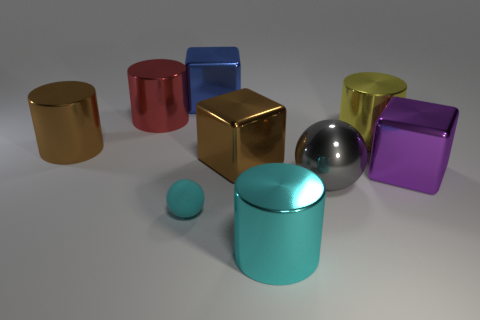Subtract 1 cylinders. How many cylinders are left? 3 Add 1 big cyan objects. How many objects exist? 10 Subtract all cubes. How many objects are left? 6 Add 4 large brown shiny things. How many large brown shiny things exist? 6 Subtract 1 blue cubes. How many objects are left? 8 Subtract all small brown metal cylinders. Subtract all blue metal blocks. How many objects are left? 8 Add 7 big red metallic objects. How many big red metallic objects are left? 8 